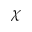<formula> <loc_0><loc_0><loc_500><loc_500>\chi</formula> 